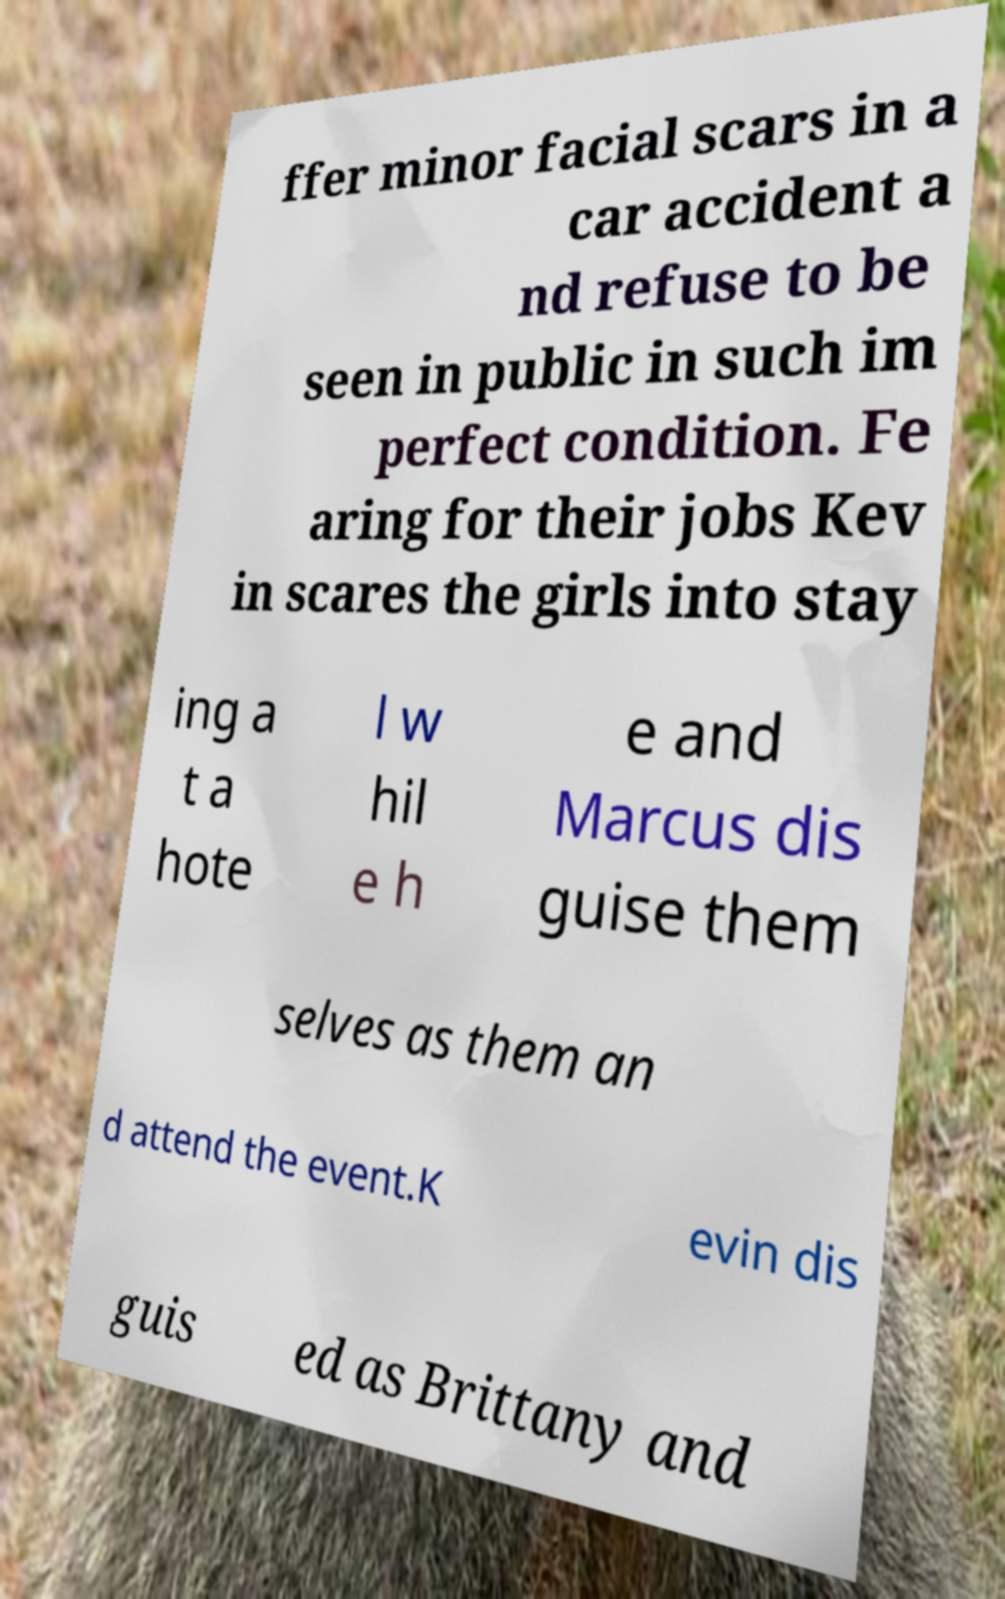Could you assist in decoding the text presented in this image and type it out clearly? ffer minor facial scars in a car accident a nd refuse to be seen in public in such im perfect condition. Fe aring for their jobs Kev in scares the girls into stay ing a t a hote l w hil e h e and Marcus dis guise them selves as them an d attend the event.K evin dis guis ed as Brittany and 